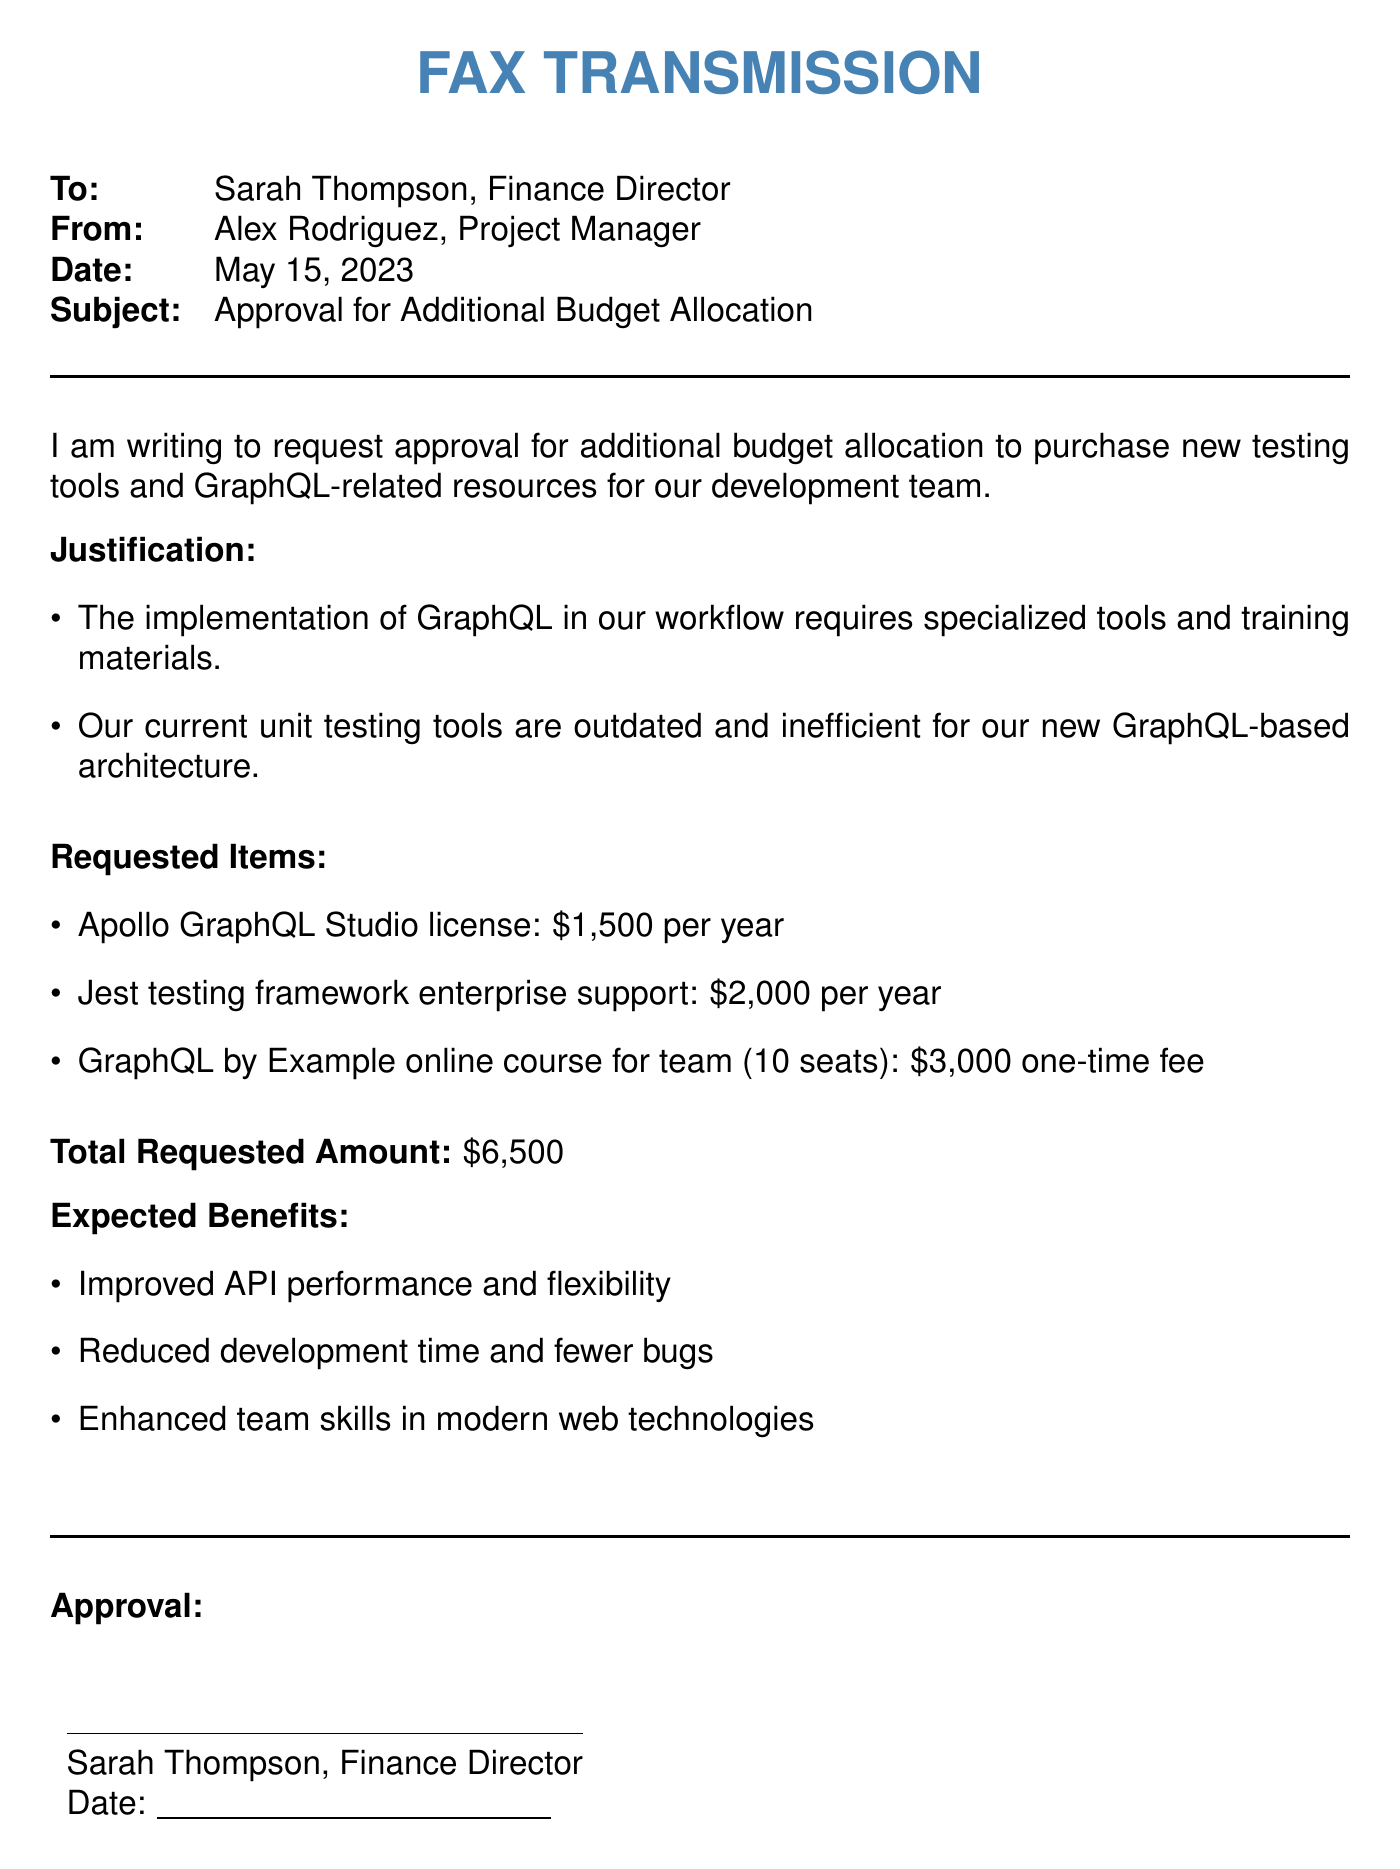What is the date of the fax? The date is located in the header section of the fax document.
Answer: May 15, 2023 Who is the sender of the fax? The sender's name is listed in the From section of the fax.
Answer: Alex Rodriguez What is the total requested amount? The total requested amount is specified in the document.
Answer: $6,500 What is one of the requested items? The requested items are listed in a bullet point format in the document.
Answer: Apollo GraphQL Studio license What is the purpose of this fax? The purpose is described at the beginning of the fax document.
Answer: Approval for Additional Budget Allocation Why is there a need for new tools? The justification for new tools is provided in the document.
Answer: Outdated and inefficient current tools What is one expected benefit listed? The expected benefits are detailed in a bullet point format in the document.
Answer: Improved API performance Who needs to approve this request? The approval section indicates who needs to give approval.
Answer: Sarah Thompson, Finance Director 